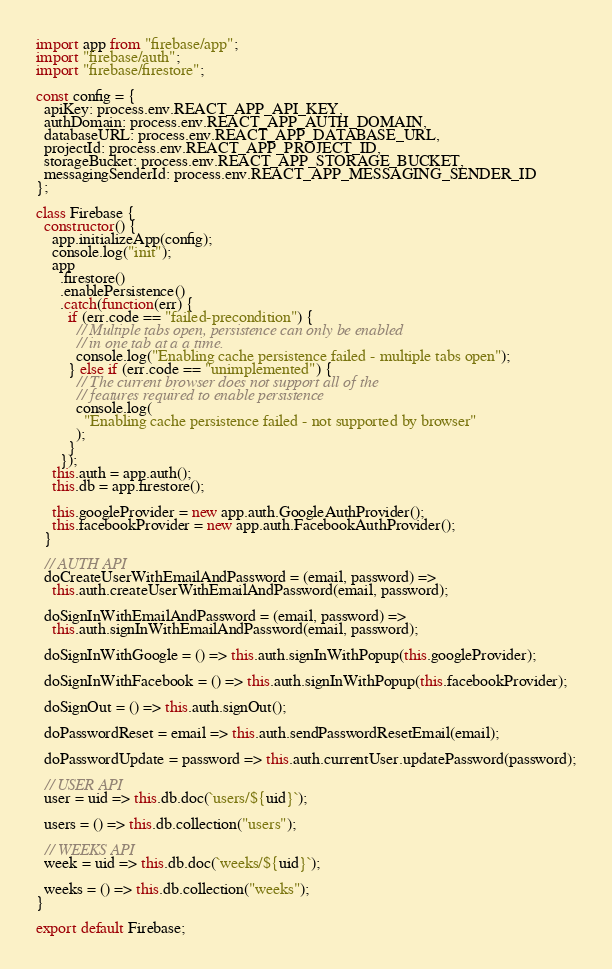Convert code to text. <code><loc_0><loc_0><loc_500><loc_500><_JavaScript_>import app from "firebase/app";
import "firebase/auth";
import "firebase/firestore";

const config = {
  apiKey: process.env.REACT_APP_API_KEY,
  authDomain: process.env.REACT_APP_AUTH_DOMAIN,
  databaseURL: process.env.REACT_APP_DATABASE_URL,
  projectId: process.env.REACT_APP_PROJECT_ID,
  storageBucket: process.env.REACT_APP_STORAGE_BUCKET,
  messagingSenderId: process.env.REACT_APP_MESSAGING_SENDER_ID
};

class Firebase {
  constructor() {
    app.initializeApp(config);
    console.log("init");
    app
      .firestore()
      .enablePersistence()
      .catch(function(err) {
        if (err.code == "failed-precondition") {
          // Multiple tabs open, persistence can only be enabled
          // in one tab at a a time.
          console.log("Enabling cache persistence failed - multiple tabs open");
        } else if (err.code == "unimplemented") {
          // The current browser does not support all of the
          // features required to enable persistence
          console.log(
            "Enabling cache persistence failed - not supported by browser"
          );
        }
      });
    this.auth = app.auth();
    this.db = app.firestore();

    this.googleProvider = new app.auth.GoogleAuthProvider();
    this.facebookProvider = new app.auth.FacebookAuthProvider();
  }

  // AUTH API
  doCreateUserWithEmailAndPassword = (email, password) =>
    this.auth.createUserWithEmailAndPassword(email, password);

  doSignInWithEmailAndPassword = (email, password) =>
    this.auth.signInWithEmailAndPassword(email, password);

  doSignInWithGoogle = () => this.auth.signInWithPopup(this.googleProvider);

  doSignInWithFacebook = () => this.auth.signInWithPopup(this.facebookProvider);

  doSignOut = () => this.auth.signOut();

  doPasswordReset = email => this.auth.sendPasswordResetEmail(email);

  doPasswordUpdate = password => this.auth.currentUser.updatePassword(password);

  // USER API
  user = uid => this.db.doc(`users/${uid}`);

  users = () => this.db.collection("users");

  // WEEKS API
  week = uid => this.db.doc(`weeks/${uid}`);

  weeks = () => this.db.collection("weeks");
}

export default Firebase;
</code> 